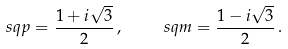Convert formula to latex. <formula><loc_0><loc_0><loc_500><loc_500>\ s q p = \frac { 1 + i \sqrt { 3 } } { 2 } \, , \quad \ s q m = \frac { 1 - i \sqrt { 3 } } { 2 } \, .</formula> 